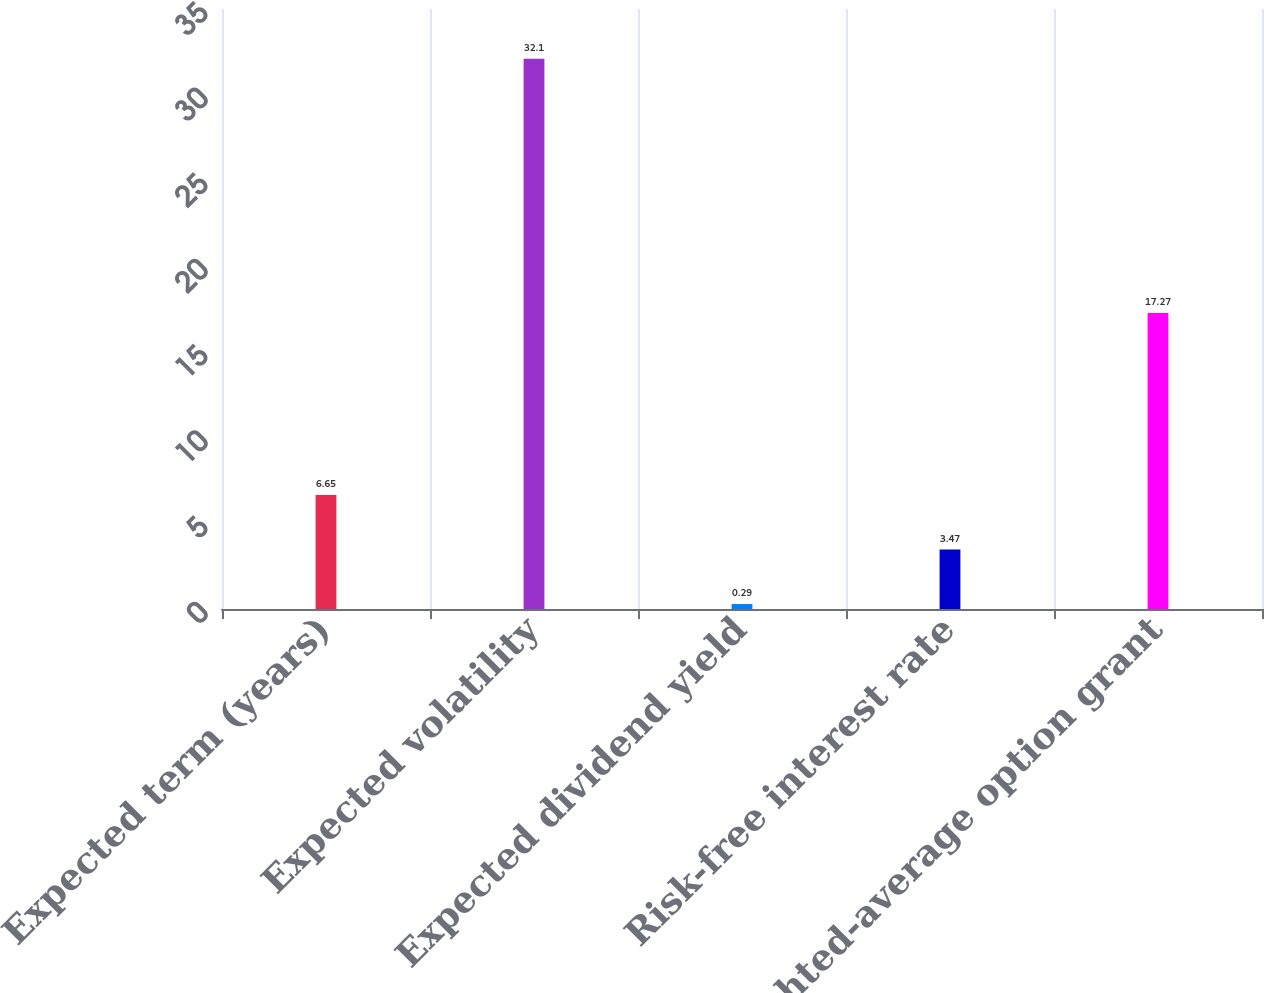Convert chart. <chart><loc_0><loc_0><loc_500><loc_500><bar_chart><fcel>Expected term (years)<fcel>Expected volatility<fcel>Expected dividend yield<fcel>Risk-free interest rate<fcel>Weighted-average option grant<nl><fcel>6.65<fcel>32.1<fcel>0.29<fcel>3.47<fcel>17.27<nl></chart> 